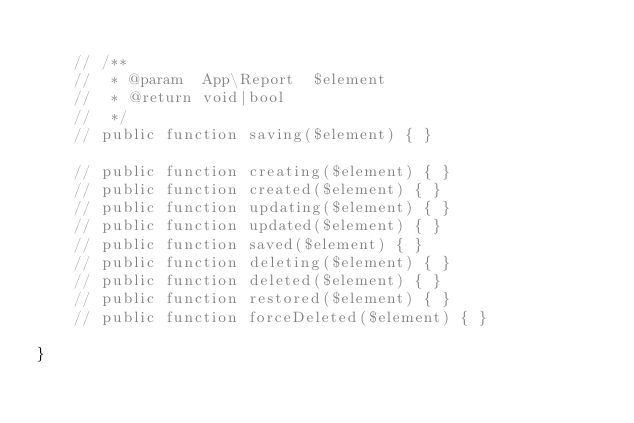<code> <loc_0><loc_0><loc_500><loc_500><_PHP_>
    // /**
    //  * @param  App\Report  $element
    //  * @return void|bool
    //  */
    // public function saving($element) { }

    // public function creating($element) { }
    // public function created($element) { }
    // public function updating($element) { }
    // public function updated($element) { }
    // public function saved($element) { }
    // public function deleting($element) { }
    // public function deleted($element) { }
    // public function restored($element) { }
    // public function forceDeleted($element) { }

}</code> 